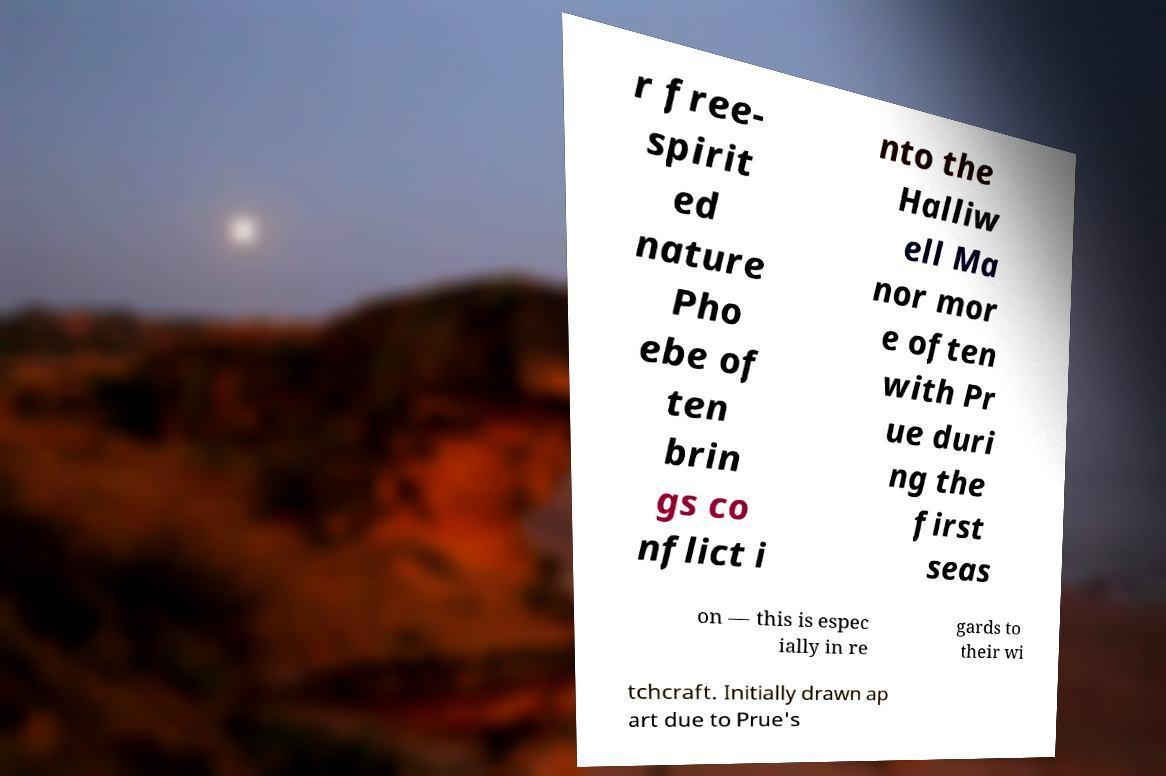Please identify and transcribe the text found in this image. r free- spirit ed nature Pho ebe of ten brin gs co nflict i nto the Halliw ell Ma nor mor e often with Pr ue duri ng the first seas on — this is espec ially in re gards to their wi tchcraft. Initially drawn ap art due to Prue's 